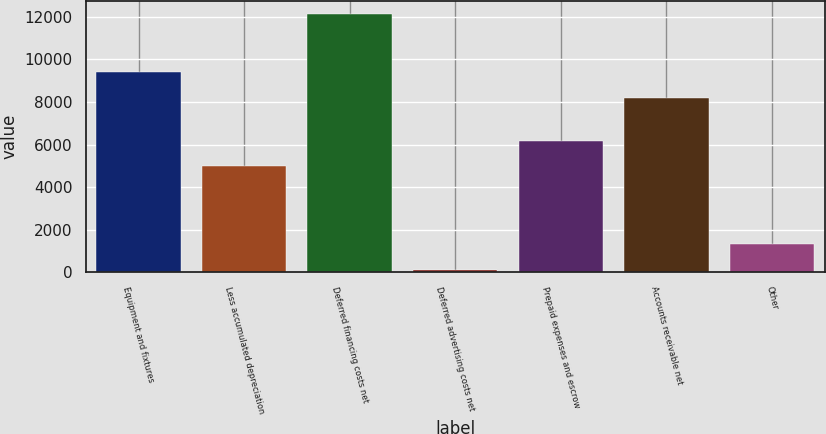Convert chart. <chart><loc_0><loc_0><loc_500><loc_500><bar_chart><fcel>Equipment and fixtures<fcel>Less accumulated depreciation<fcel>Deferred financing costs net<fcel>Deferred advertising costs net<fcel>Prepaid expenses and escrow<fcel>Accounts receivable net<fcel>Other<nl><fcel>9389<fcel>4977<fcel>12151<fcel>128<fcel>6179.3<fcel>8179<fcel>1330.3<nl></chart> 